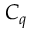<formula> <loc_0><loc_0><loc_500><loc_500>C _ { q }</formula> 